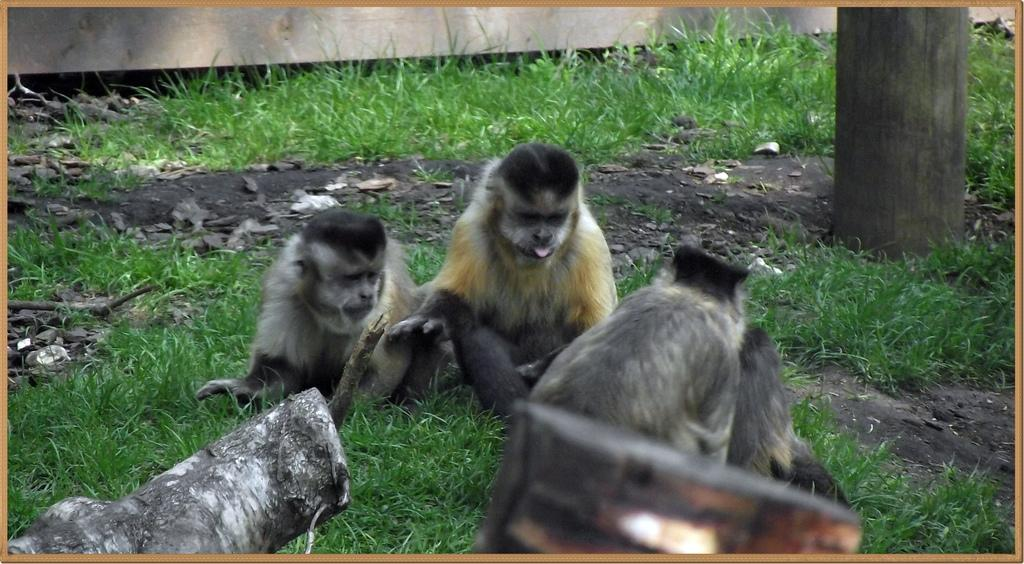What types of living organisms can be seen in the image? There are animals in the image. What type of vegetation is visible in the image? There is grass and leaves present in the image. What material is used for the objects in the image? There are wooden objects in the image. What part of a tree can be seen in the image? There is a tree trunk in the image. How does the sister interact with the animals in the image? There is no sister present in the image; it only features animals, grass, wooden objects, leaves, and a tree trunk. 